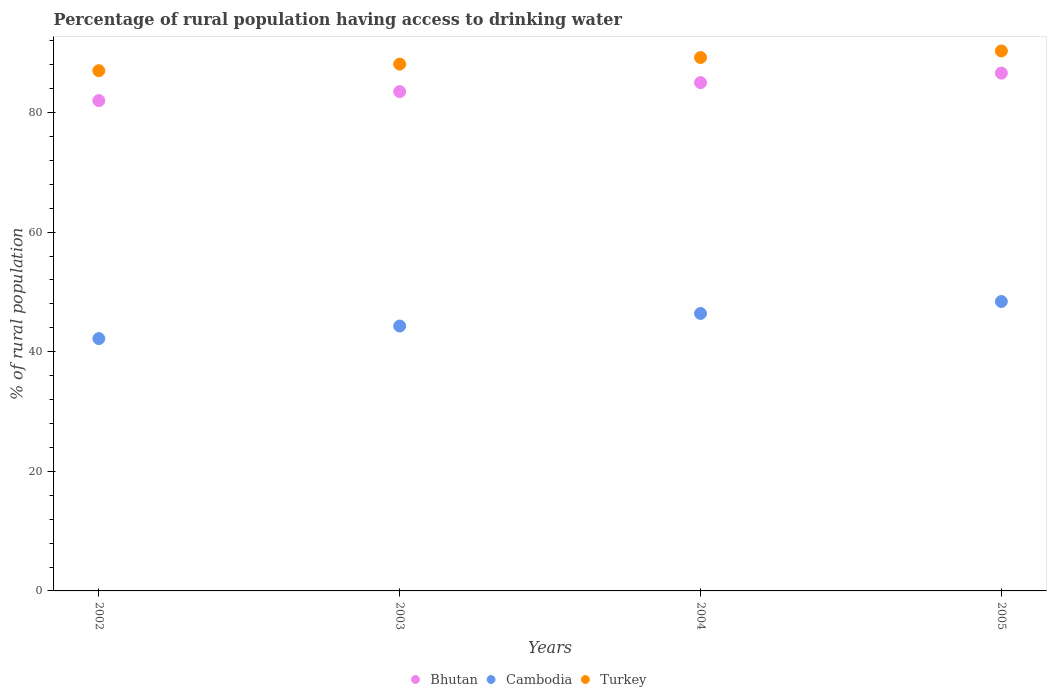How many different coloured dotlines are there?
Provide a succinct answer. 3. Is the number of dotlines equal to the number of legend labels?
Give a very brief answer. Yes. What is the percentage of rural population having access to drinking water in Cambodia in 2002?
Make the answer very short. 42.2. Across all years, what is the maximum percentage of rural population having access to drinking water in Cambodia?
Give a very brief answer. 48.4. Across all years, what is the minimum percentage of rural population having access to drinking water in Cambodia?
Give a very brief answer. 42.2. In which year was the percentage of rural population having access to drinking water in Cambodia maximum?
Your answer should be compact. 2005. What is the total percentage of rural population having access to drinking water in Cambodia in the graph?
Keep it short and to the point. 181.3. What is the difference between the percentage of rural population having access to drinking water in Cambodia in 2002 and that in 2003?
Your response must be concise. -2.1. What is the difference between the percentage of rural population having access to drinking water in Cambodia in 2004 and the percentage of rural population having access to drinking water in Bhutan in 2003?
Ensure brevity in your answer.  -37.1. What is the average percentage of rural population having access to drinking water in Turkey per year?
Offer a very short reply. 88.65. In the year 2003, what is the difference between the percentage of rural population having access to drinking water in Cambodia and percentage of rural population having access to drinking water in Bhutan?
Provide a short and direct response. -39.2. What is the ratio of the percentage of rural population having access to drinking water in Bhutan in 2002 to that in 2004?
Make the answer very short. 0.96. Is the difference between the percentage of rural population having access to drinking water in Cambodia in 2003 and 2005 greater than the difference between the percentage of rural population having access to drinking water in Bhutan in 2003 and 2005?
Your answer should be compact. No. What is the difference between the highest and the lowest percentage of rural population having access to drinking water in Turkey?
Ensure brevity in your answer.  3.3. In how many years, is the percentage of rural population having access to drinking water in Bhutan greater than the average percentage of rural population having access to drinking water in Bhutan taken over all years?
Make the answer very short. 2. Is it the case that in every year, the sum of the percentage of rural population having access to drinking water in Turkey and percentage of rural population having access to drinking water in Bhutan  is greater than the percentage of rural population having access to drinking water in Cambodia?
Keep it short and to the point. Yes. Is the percentage of rural population having access to drinking water in Turkey strictly greater than the percentage of rural population having access to drinking water in Bhutan over the years?
Give a very brief answer. Yes. Is the percentage of rural population having access to drinking water in Cambodia strictly less than the percentage of rural population having access to drinking water in Turkey over the years?
Your answer should be very brief. Yes. How many years are there in the graph?
Make the answer very short. 4. Are the values on the major ticks of Y-axis written in scientific E-notation?
Your response must be concise. No. Does the graph contain grids?
Ensure brevity in your answer.  No. What is the title of the graph?
Keep it short and to the point. Percentage of rural population having access to drinking water. What is the label or title of the X-axis?
Offer a very short reply. Years. What is the label or title of the Y-axis?
Keep it short and to the point. % of rural population. What is the % of rural population in Cambodia in 2002?
Your response must be concise. 42.2. What is the % of rural population in Turkey in 2002?
Offer a very short reply. 87. What is the % of rural population of Bhutan in 2003?
Offer a terse response. 83.5. What is the % of rural population of Cambodia in 2003?
Your answer should be very brief. 44.3. What is the % of rural population in Turkey in 2003?
Your answer should be compact. 88.1. What is the % of rural population in Cambodia in 2004?
Your answer should be very brief. 46.4. What is the % of rural population of Turkey in 2004?
Your answer should be very brief. 89.2. What is the % of rural population in Bhutan in 2005?
Provide a short and direct response. 86.6. What is the % of rural population in Cambodia in 2005?
Your answer should be very brief. 48.4. What is the % of rural population of Turkey in 2005?
Your answer should be very brief. 90.3. Across all years, what is the maximum % of rural population of Bhutan?
Your response must be concise. 86.6. Across all years, what is the maximum % of rural population of Cambodia?
Make the answer very short. 48.4. Across all years, what is the maximum % of rural population of Turkey?
Make the answer very short. 90.3. Across all years, what is the minimum % of rural population of Cambodia?
Give a very brief answer. 42.2. What is the total % of rural population of Bhutan in the graph?
Your answer should be very brief. 337.1. What is the total % of rural population in Cambodia in the graph?
Ensure brevity in your answer.  181.3. What is the total % of rural population of Turkey in the graph?
Your response must be concise. 354.6. What is the difference between the % of rural population in Bhutan in 2002 and that in 2003?
Offer a very short reply. -1.5. What is the difference between the % of rural population of Cambodia in 2002 and that in 2003?
Make the answer very short. -2.1. What is the difference between the % of rural population of Turkey in 2002 and that in 2003?
Provide a short and direct response. -1.1. What is the difference between the % of rural population of Bhutan in 2003 and that in 2004?
Offer a very short reply. -1.5. What is the difference between the % of rural population in Cambodia in 2003 and that in 2004?
Your answer should be compact. -2.1. What is the difference between the % of rural population in Turkey in 2003 and that in 2005?
Ensure brevity in your answer.  -2.2. What is the difference between the % of rural population of Cambodia in 2004 and that in 2005?
Ensure brevity in your answer.  -2. What is the difference between the % of rural population of Turkey in 2004 and that in 2005?
Provide a short and direct response. -1.1. What is the difference between the % of rural population of Bhutan in 2002 and the % of rural population of Cambodia in 2003?
Provide a succinct answer. 37.7. What is the difference between the % of rural population in Cambodia in 2002 and the % of rural population in Turkey in 2003?
Make the answer very short. -45.9. What is the difference between the % of rural population in Bhutan in 2002 and the % of rural population in Cambodia in 2004?
Offer a very short reply. 35.6. What is the difference between the % of rural population in Cambodia in 2002 and the % of rural population in Turkey in 2004?
Make the answer very short. -47. What is the difference between the % of rural population in Bhutan in 2002 and the % of rural population in Cambodia in 2005?
Make the answer very short. 33.6. What is the difference between the % of rural population in Cambodia in 2002 and the % of rural population in Turkey in 2005?
Offer a very short reply. -48.1. What is the difference between the % of rural population in Bhutan in 2003 and the % of rural population in Cambodia in 2004?
Give a very brief answer. 37.1. What is the difference between the % of rural population of Bhutan in 2003 and the % of rural population of Turkey in 2004?
Your answer should be compact. -5.7. What is the difference between the % of rural population of Cambodia in 2003 and the % of rural population of Turkey in 2004?
Keep it short and to the point. -44.9. What is the difference between the % of rural population of Bhutan in 2003 and the % of rural population of Cambodia in 2005?
Provide a short and direct response. 35.1. What is the difference between the % of rural population in Cambodia in 2003 and the % of rural population in Turkey in 2005?
Ensure brevity in your answer.  -46. What is the difference between the % of rural population of Bhutan in 2004 and the % of rural population of Cambodia in 2005?
Your answer should be compact. 36.6. What is the difference between the % of rural population of Bhutan in 2004 and the % of rural population of Turkey in 2005?
Provide a short and direct response. -5.3. What is the difference between the % of rural population of Cambodia in 2004 and the % of rural population of Turkey in 2005?
Give a very brief answer. -43.9. What is the average % of rural population of Bhutan per year?
Your response must be concise. 84.28. What is the average % of rural population of Cambodia per year?
Your response must be concise. 45.33. What is the average % of rural population in Turkey per year?
Keep it short and to the point. 88.65. In the year 2002, what is the difference between the % of rural population of Bhutan and % of rural population of Cambodia?
Offer a very short reply. 39.8. In the year 2002, what is the difference between the % of rural population in Cambodia and % of rural population in Turkey?
Your response must be concise. -44.8. In the year 2003, what is the difference between the % of rural population of Bhutan and % of rural population of Cambodia?
Offer a very short reply. 39.2. In the year 2003, what is the difference between the % of rural population in Bhutan and % of rural population in Turkey?
Ensure brevity in your answer.  -4.6. In the year 2003, what is the difference between the % of rural population in Cambodia and % of rural population in Turkey?
Keep it short and to the point. -43.8. In the year 2004, what is the difference between the % of rural population of Bhutan and % of rural population of Cambodia?
Ensure brevity in your answer.  38.6. In the year 2004, what is the difference between the % of rural population in Cambodia and % of rural population in Turkey?
Your answer should be compact. -42.8. In the year 2005, what is the difference between the % of rural population of Bhutan and % of rural population of Cambodia?
Make the answer very short. 38.2. In the year 2005, what is the difference between the % of rural population of Bhutan and % of rural population of Turkey?
Your response must be concise. -3.7. In the year 2005, what is the difference between the % of rural population of Cambodia and % of rural population of Turkey?
Provide a short and direct response. -41.9. What is the ratio of the % of rural population of Cambodia in 2002 to that in 2003?
Provide a succinct answer. 0.95. What is the ratio of the % of rural population of Turkey in 2002 to that in 2003?
Offer a very short reply. 0.99. What is the ratio of the % of rural population in Bhutan in 2002 to that in 2004?
Your response must be concise. 0.96. What is the ratio of the % of rural population of Cambodia in 2002 to that in 2004?
Offer a very short reply. 0.91. What is the ratio of the % of rural population in Turkey in 2002 to that in 2004?
Provide a succinct answer. 0.98. What is the ratio of the % of rural population of Bhutan in 2002 to that in 2005?
Provide a succinct answer. 0.95. What is the ratio of the % of rural population of Cambodia in 2002 to that in 2005?
Provide a short and direct response. 0.87. What is the ratio of the % of rural population of Turkey in 2002 to that in 2005?
Keep it short and to the point. 0.96. What is the ratio of the % of rural population of Bhutan in 2003 to that in 2004?
Your response must be concise. 0.98. What is the ratio of the % of rural population of Cambodia in 2003 to that in 2004?
Offer a terse response. 0.95. What is the ratio of the % of rural population of Bhutan in 2003 to that in 2005?
Give a very brief answer. 0.96. What is the ratio of the % of rural population in Cambodia in 2003 to that in 2005?
Provide a short and direct response. 0.92. What is the ratio of the % of rural population of Turkey in 2003 to that in 2005?
Ensure brevity in your answer.  0.98. What is the ratio of the % of rural population in Bhutan in 2004 to that in 2005?
Offer a very short reply. 0.98. What is the ratio of the % of rural population in Cambodia in 2004 to that in 2005?
Keep it short and to the point. 0.96. What is the ratio of the % of rural population in Turkey in 2004 to that in 2005?
Your answer should be very brief. 0.99. What is the difference between the highest and the second highest % of rural population in Bhutan?
Keep it short and to the point. 1.6. What is the difference between the highest and the second highest % of rural population in Turkey?
Make the answer very short. 1.1. What is the difference between the highest and the lowest % of rural population in Bhutan?
Offer a terse response. 4.6. 